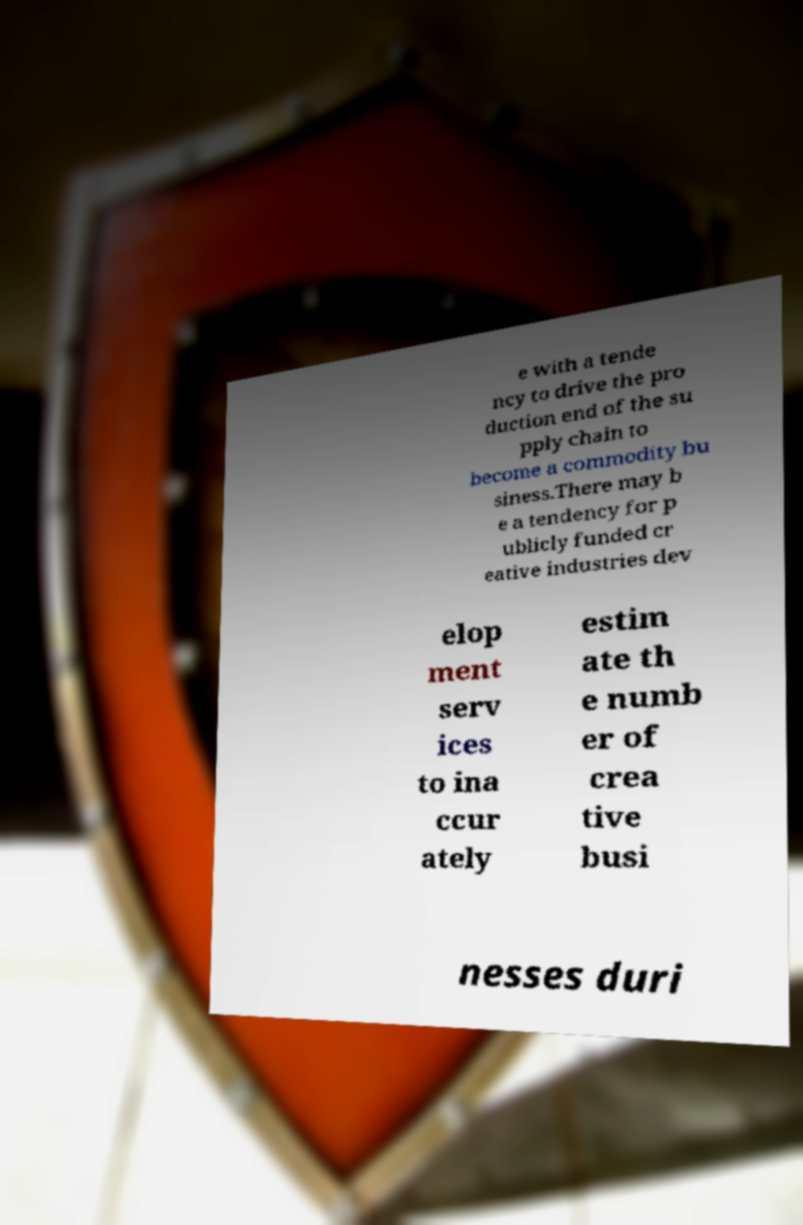Please identify and transcribe the text found in this image. e with a tende ncy to drive the pro duction end of the su pply chain to become a commodity bu siness.There may b e a tendency for p ublicly funded cr eative industries dev elop ment serv ices to ina ccur ately estim ate th e numb er of crea tive busi nesses duri 